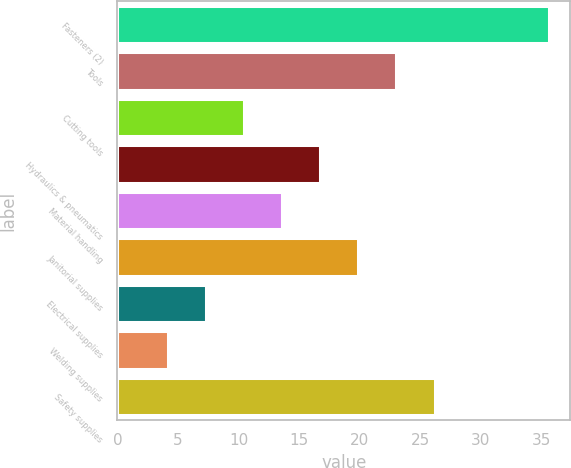<chart> <loc_0><loc_0><loc_500><loc_500><bar_chart><fcel>Fasteners (2)<fcel>Tools<fcel>Cutting tools<fcel>Hydraulics & pneumatics<fcel>Material handling<fcel>Janitorial supplies<fcel>Electrical supplies<fcel>Welding supplies<fcel>Safety supplies<nl><fcel>35.6<fcel>23.04<fcel>10.48<fcel>16.76<fcel>13.62<fcel>19.9<fcel>7.34<fcel>4.2<fcel>26.18<nl></chart> 